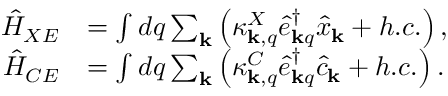<formula> <loc_0><loc_0><loc_500><loc_500>\begin{array} { r l } { \hat { H } _ { X E } } & { = \int d q \sum _ { k } \left ( \kappa _ { { k } , q } ^ { X } \hat { e } _ { { k } q } ^ { \dagger } \hat { x } _ { k } + h . c . \right ) , } \\ { \hat { H } _ { C E } } & { = \int d q \sum _ { k } \left ( \kappa _ { { k } , q } ^ { C } \hat { e } _ { { k } q } ^ { \dagger } \hat { c } _ { k } + h . c . \right ) . } \end{array}</formula> 